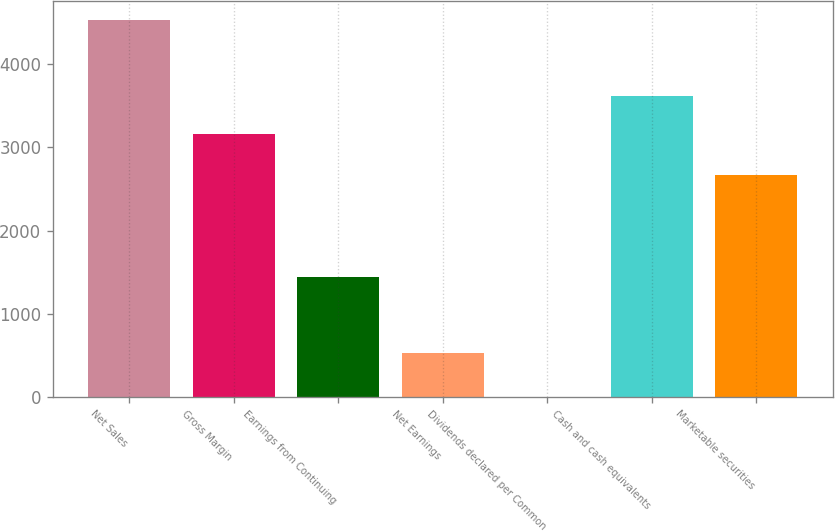Convert chart to OTSL. <chart><loc_0><loc_0><loc_500><loc_500><bar_chart><fcel>Net Sales<fcel>Gross Margin<fcel>Earnings from Continuing<fcel>Net Earnings<fcel>Dividends declared per Common<fcel>Cash and cash equivalents<fcel>Marketable securities<nl><fcel>4532<fcel>3165<fcel>1439.34<fcel>533<fcel>0.28<fcel>3618.17<fcel>2671<nl></chart> 